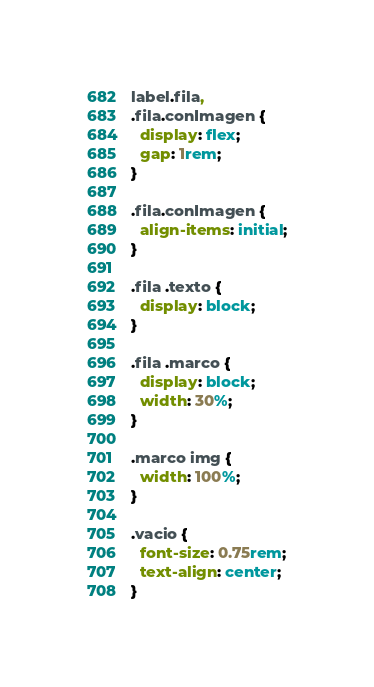Convert code to text. <code><loc_0><loc_0><loc_500><loc_500><_CSS_>label.fila,
.fila.conImagen {
  display: flex;
  gap: 1rem;
}

.fila.conImagen {
  align-items: initial;
}

.fila .texto {
  display: block;
}

.fila .marco {
  display: block;
  width: 30%;
}

.marco img {
  width: 100%;
}

.vacio {
  font-size: 0.75rem;
  text-align: center;
}
</code> 